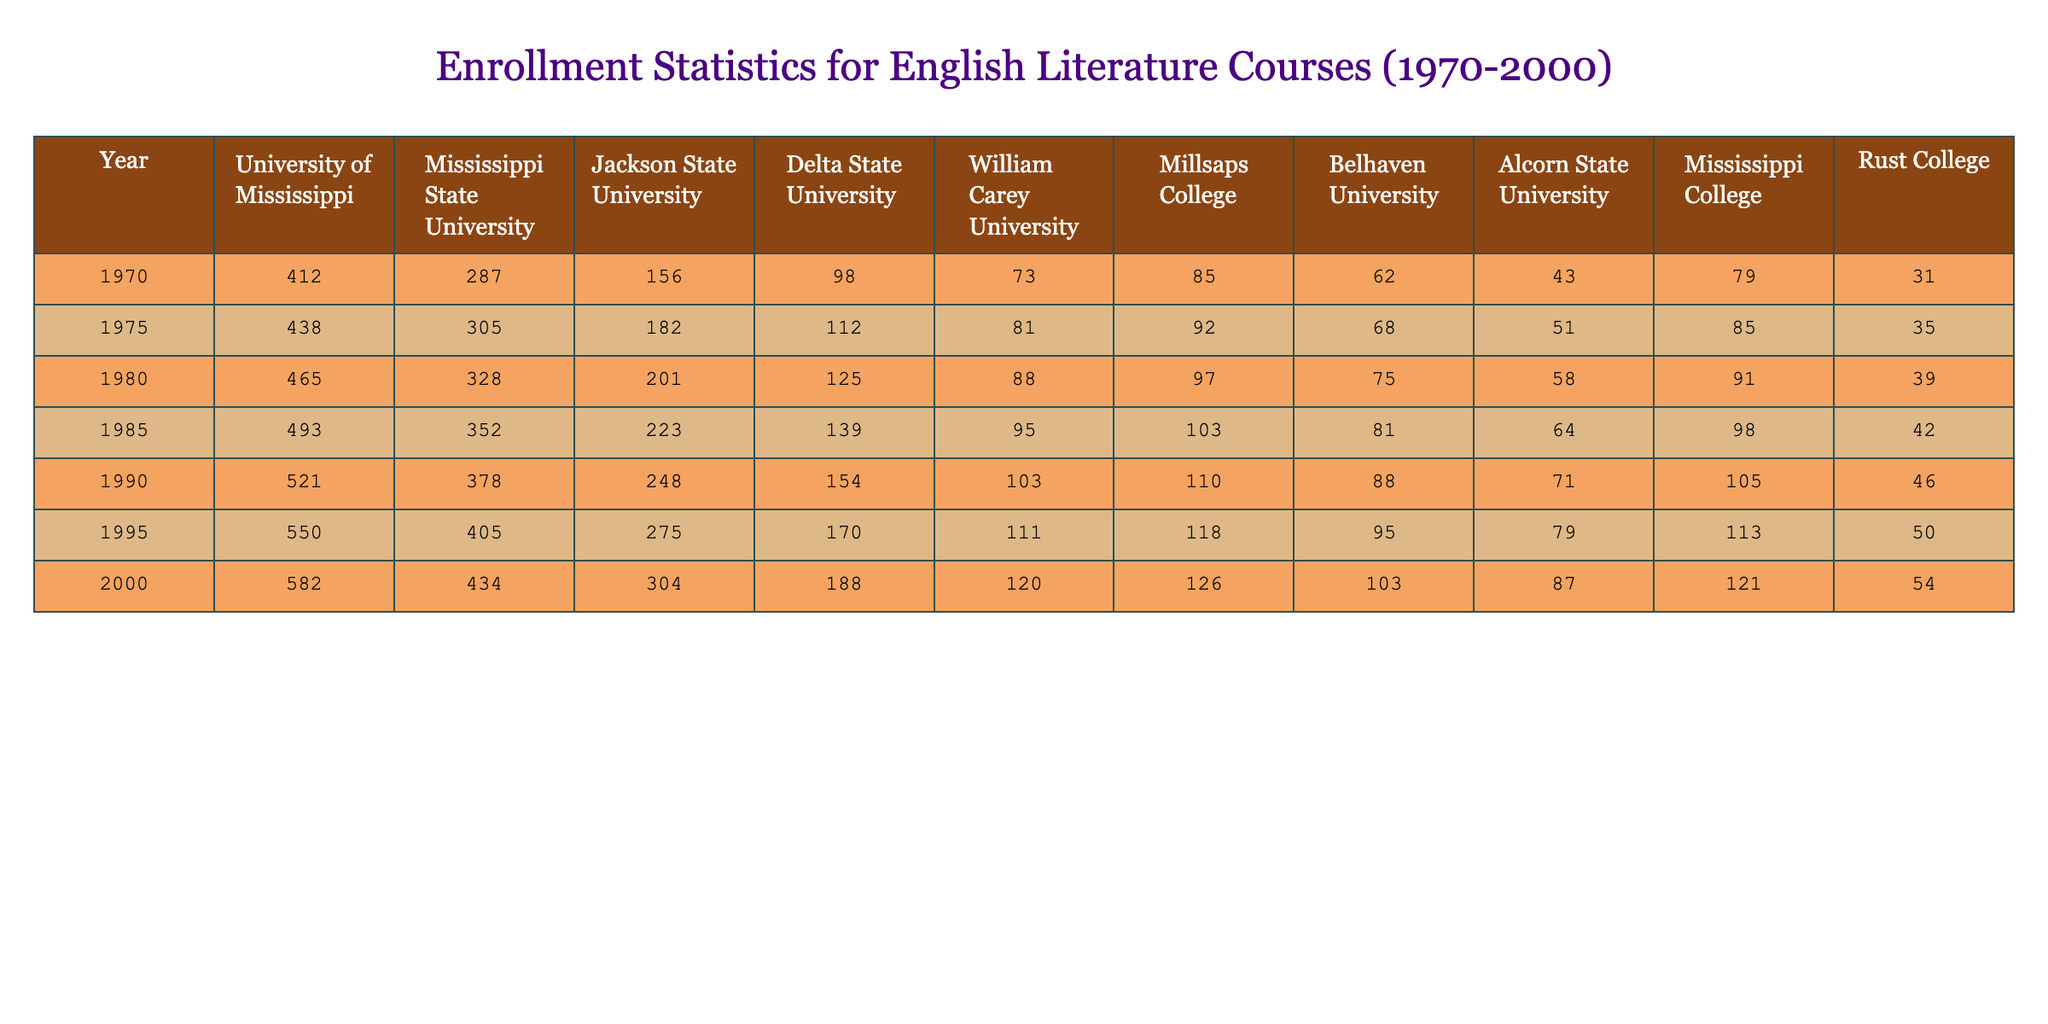What was the enrollment for English literature courses at the University of Mississippi in 1990? The table lists the enrollment for the University of Mississippi in 1990 as 521 students.
Answer: 521 Which university had the highest enrollment in 1985? According to the table, the Mississippi State University had the highest enrollment in 1985 with 352 students.
Answer: Mississippi State University How many students were enrolled at Delta State University in 2000? The table shows that Delta State University had 188 students enrolled in 2000.
Answer: 188 What was the trend in enrollment at Jackson State University from 1970 to 2000? By looking at the columns for Jackson State University, the enrollment increased from 156 in 1970 to 304 in 2000, indicating an upward trend.
Answer: Upward trend What is the average enrollment across all universities in 1995? The total enrollment for all universities in 1995 is 550 + 405 + 275 + 170 + 111 + 118 + 95 + 79 + 113 + 50 = 2066. The average is 2066 divided by 10, which equals 206.6.
Answer: 206.6 In which year did Alcorn State University have the lowest enrollment? Looking at the Alcorn State University row, the lowest enrollment was in 1970 with just 43 students.
Answer: 1970 Did enrollment at Rust College increase in every five-year period from 1970 to 2000? By assessing the Rust College row, the enrollments are 31 (1970), 35 (1975), 39 (1980), 42 (1985), 46 (1990), 50 (1995), and 54 (2000), showing consistent increases, so yes, it did increase every five years.
Answer: Yes What was the percentage increase in enrollment at Millsaps College from 1970 to 2000? Millsaps College had an enrollment of 85 in 1970 and 126 in 2000. The increase is 126 - 85 = 41. The percentage increase is (41/85) * 100 = 48.24%.
Answer: 48.24% Which university had the lowest enrollment in 1990? Looking at the 1990 row, Rust College had the lowest enrollment with 46 students.
Answer: Rust College Calculate the total enrollment for all universities in 1980. The total enrollment for 1980 is the sum of all individual enrollments: 465 + 328 + 201 + 125 + 88 + 97 + 75 + 58 + 91 + 39 = 1566.
Answer: 1566 